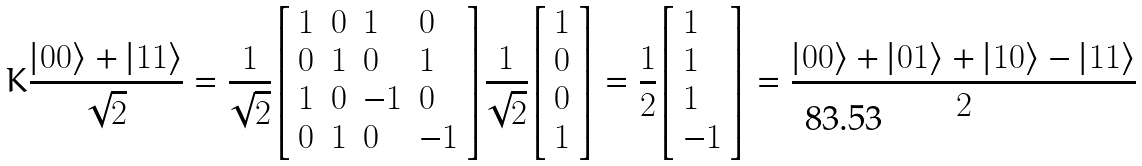<formula> <loc_0><loc_0><loc_500><loc_500>K { \frac { | 0 0 \rangle + | 1 1 \rangle } { \sqrt { 2 } } } = { \frac { 1 } { \sqrt { 2 } } } { \left [ \begin{array} { l l l l } { 1 } & { 0 } & { 1 } & { 0 } \\ { 0 } & { 1 } & { 0 } & { 1 } \\ { 1 } & { 0 } & { - 1 } & { 0 } \\ { 0 } & { 1 } & { 0 } & { - 1 } \end{array} \right ] } { \frac { 1 } { \sqrt { 2 } } } { \left [ \begin{array} { l } { 1 } \\ { 0 } \\ { 0 } \\ { 1 } \end{array} \right ] } = { \frac { 1 } { 2 } } { \left [ \begin{array} { l } { 1 } \\ { 1 } \\ { 1 } \\ { - 1 } \end{array} \right ] } = { \frac { | 0 0 \rangle + | 0 1 \rangle + | 1 0 \rangle - | 1 1 \rangle } { 2 } }</formula> 